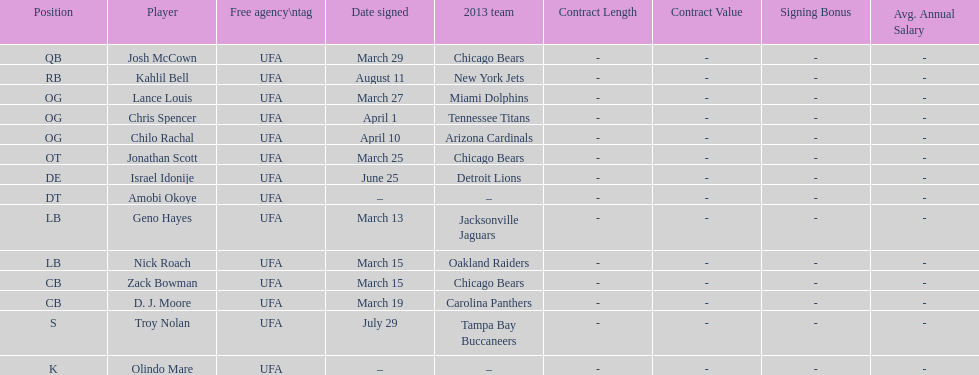Total number of players that signed in march? 7. 